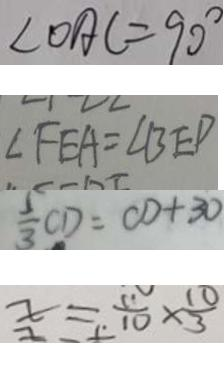<formula> <loc_0><loc_0><loc_500><loc_500>\angle O A C = 9 0 ^ { \circ } 
 \angle F E A = \angle B E D 
 \frac { 5 } { 3 } C D = C D + 3 0 
 x = \frac { 1 1 } { 1 0 } \times \frac { 1 0 } { 3 }</formula> 